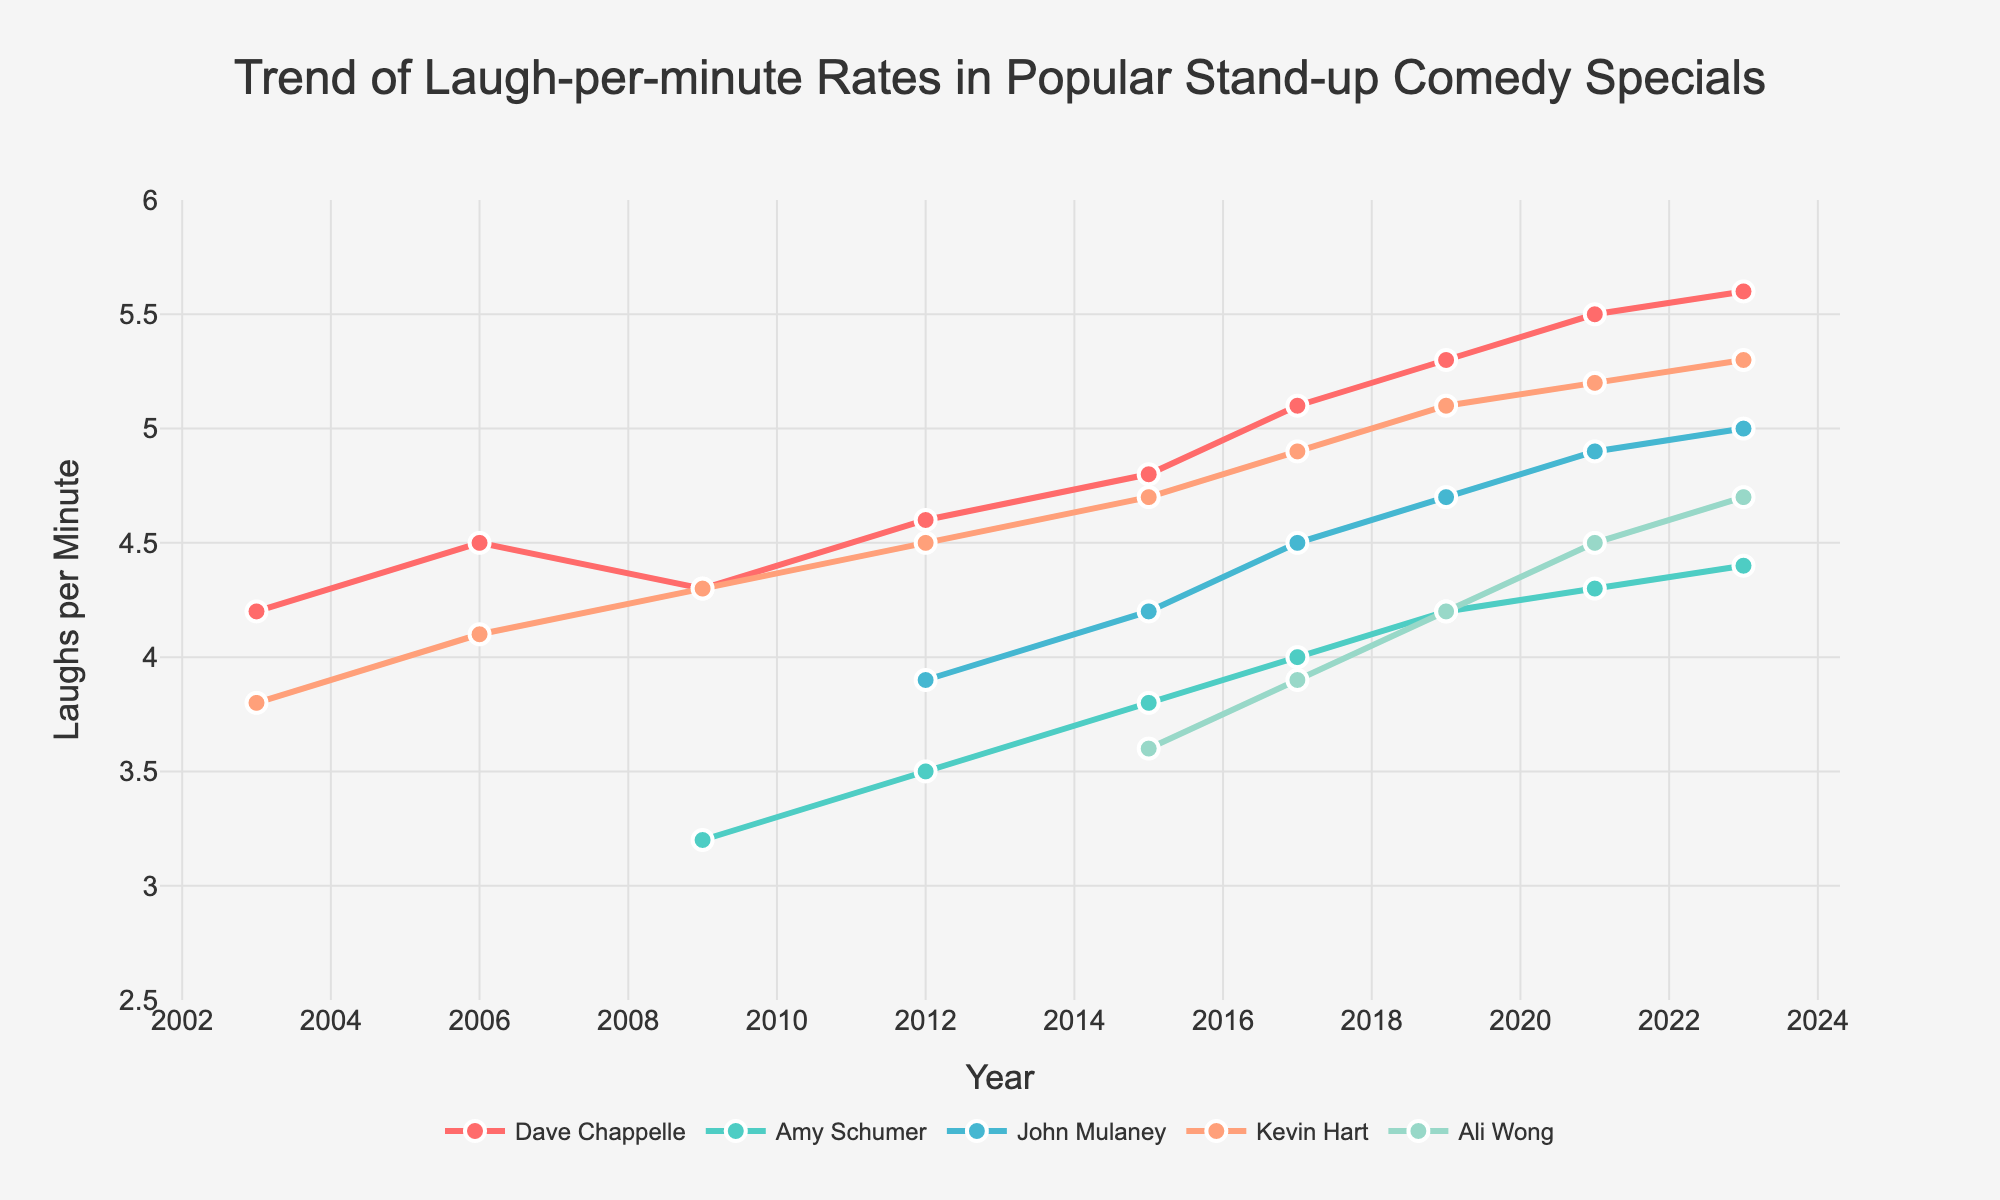Which comedian shows the greatest overall increase in laughs per minute from 2003 to 2023? To determine which comedian shows the greatest overall increase, subtract each comedian's 2003 laughs per minute rate from their 2023 rate and compare the results. Only Dave Chappelle and Kevin Hart have values in both 2003 and 2023. Dave Chappelle's increase is 5.6 - 4.2 = 1.4, and Kevin Hart's increase is 5.3 - 3.8 = 1.5.
Answer: Kevin Hart Between 2015 and 2023, which comedian's laughs per minute rate exhibited the smallest change? Calculate the difference in laughs per minute rate for each comedian between 2015 and 2023. The differences are: Dave Chappelle: 5.6 - 4.8 = 0.8, Amy Schumer: 4.4 - 3.8 = 0.6, John Mulaney: 5.0 - 4.2 = 0.8, Kevin Hart: 5.3 - 4.7 = 0.6, Ali Wong: 4.7 - 3.6 = 1.1. Amy Schumer and Kevin Hart both show the smallest change of 0.6.
Answer: Amy Schumer, Kevin Hart Who had the highest laughs per minute rate in 2023? Compare the laughs per minute rates for all comedians in 2023. Dave Chappelle: 5.6, Amy Schumer: 4.4, John Mulaney: 5.0, Kevin Hart: 5.3, Ali Wong: 4.7. The highest value is 5.6 by Dave Chappelle.
Answer: Dave Chappelle Which comedian had a continuous increase in laughter rates from 2009 to 2023? Identify the comedians whose laugh rates increased with every year from 2009 to 2023. Dave Chappelle's laugh rates increase continuously: 4.3, 4.6, 4.8, 5.1, 5.3, 5.5, 5.6. Ali Wong shows a consistent increase: 3.6, 3.9, 4.2, 4.5, 4.7.
Answer: Dave Chappelle, Ali Wong In 2019, who had the second highest laughs per minute rate? Compare the laughs per minute rates for all comedians in 2019. Dave Chappelle: 5.3, Amy Schumer: 4.2, John Mulaney: 4.7, Kevin Hart: 5.1, Ali Wong: 4.2. The second highest rate is 5.1 by Kevin Hart, with the highest being 5.3 by Dave Chappelle.
Answer: Kevin Hart 